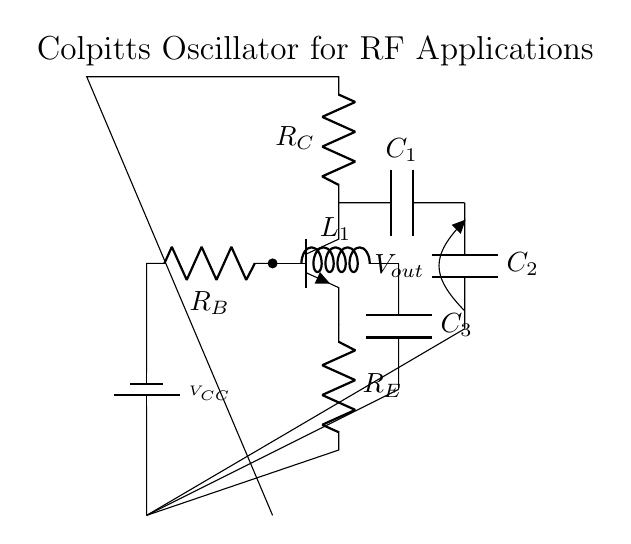What type of oscillator is represented by this circuit? The circuit is labeled as a Colpitts Oscillator, which is a specific type of oscillator characterized by its reliance on capacitive feedback for oscillation.
Answer: Colpitts What is the value of the component labeled C1? The component labeled C1 does not have a specified numeric value in the diagram; it is indicated only as a capacitor.
Answer: Not specified How many resistors are present in the circuit? The circuit includes three resistors: R_B, R_C, and R_E, each connected at different points in the circuit.
Answer: Three What component type is L1 in this circuit? The component labeled L1 is an inductor, which signifies its role in storing energy in a magnetic field for oscillations.
Answer: Inductor What output voltage is taken from the circuit? The output voltage is taken at the point labeled V_out, which indicates where the oscillating signal is accessible.
Answer: V_out Why is feedback important in this Colpitts oscillator? Feedback is crucial because it ensures the oscillations are sustained by reinforcing the output signal back into the input, which is aided by the capacitive and inductive components in the circuit.
Answer: To sustain oscillations What role do capacitors C2 and C3 play in this circuit? Capacitors C2 and C3 are part of the feedback network that determines the oscillation frequency and stability of the Colpitts oscillator, affecting its resonant characteristics.
Answer: Generate feedback 